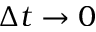<formula> <loc_0><loc_0><loc_500><loc_500>\Delta t \rightarrow 0</formula> 